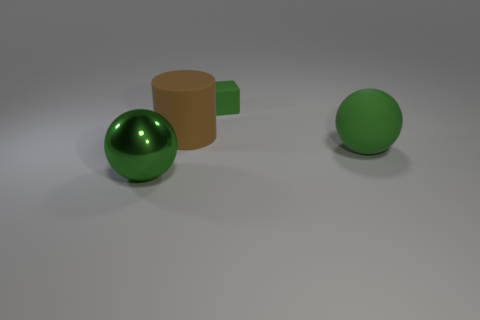Add 4 large brown matte things. How many objects exist? 8 Subtract all cylinders. How many objects are left? 3 Subtract all tiny brown matte objects. Subtract all big green spheres. How many objects are left? 2 Add 2 cubes. How many cubes are left? 3 Add 3 big blue metallic cylinders. How many big blue metallic cylinders exist? 3 Subtract 0 yellow balls. How many objects are left? 4 